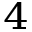<formula> <loc_0><loc_0><loc_500><loc_500>^ { 4 }</formula> 